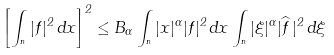<formula> <loc_0><loc_0><loc_500><loc_500>\left [ \int _ { \real ^ { n } } | f | ^ { 2 } \, d x \right ] ^ { 2 } \leq B _ { \alpha } \int _ { \real ^ { n } } | x | ^ { \alpha } | f | ^ { 2 } \, d x \int _ { \real ^ { n } } | \xi | ^ { \alpha } | \widehat { f } \, | ^ { 2 } \, d \xi</formula> 